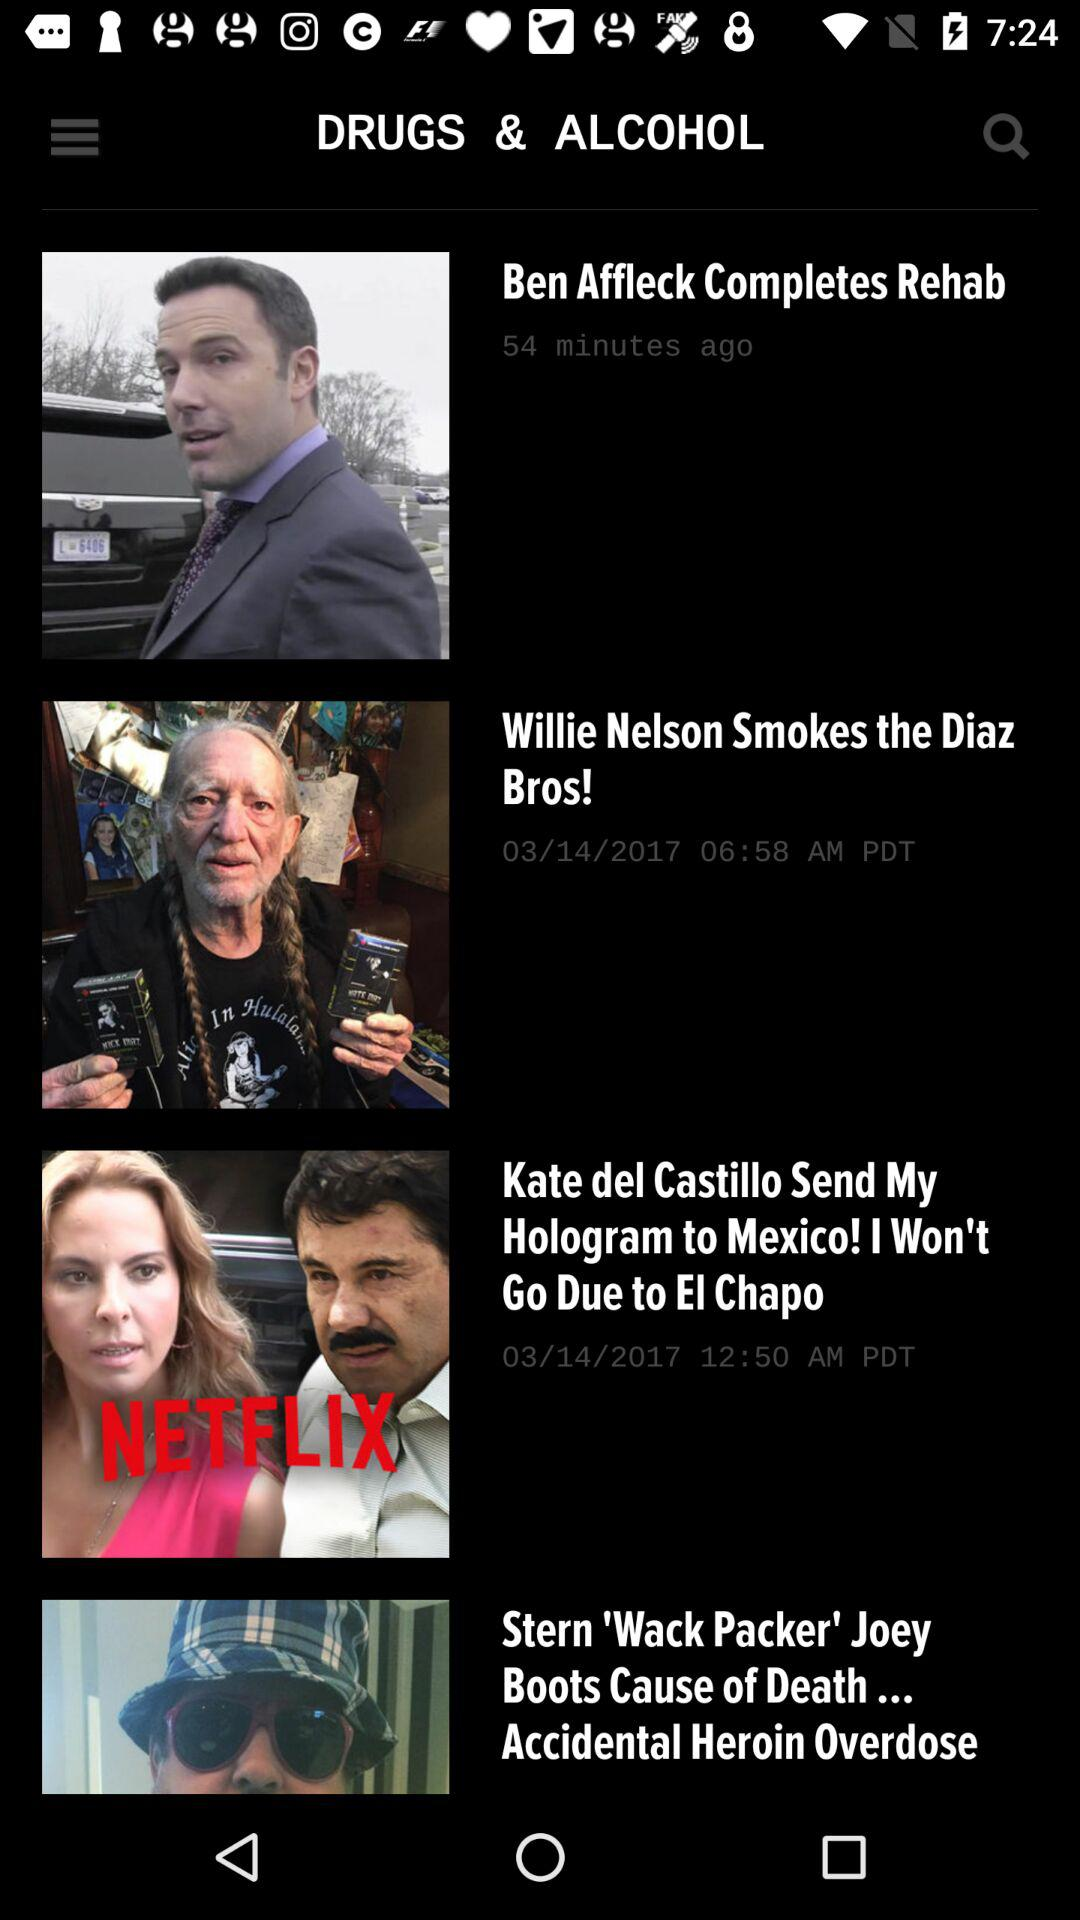When and at what time was "Willie Nelson Smokes the Diaz Bros!" news uploaded? The news was uploaded on 03/14/2017 at 06:58 AM PDT. 